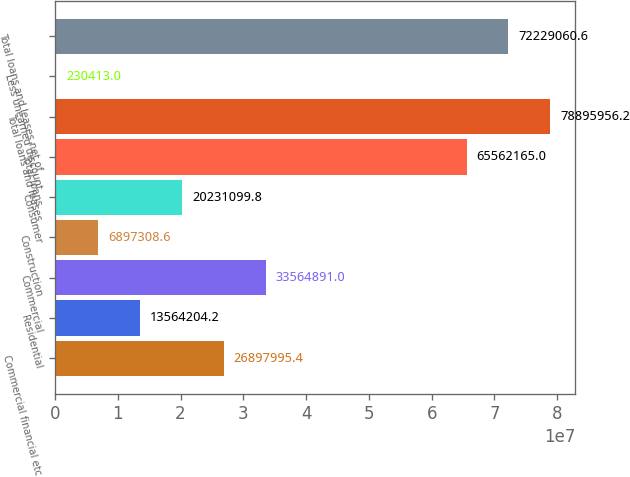Convert chart to OTSL. <chart><loc_0><loc_0><loc_500><loc_500><bar_chart><fcel>Commercial financial etc<fcel>Residential<fcel>Commercial<fcel>Construction<fcel>Consumer<fcel>Total loans<fcel>Total loans and leases<fcel>Less unearned discount<fcel>Total loans and leases net of<nl><fcel>2.6898e+07<fcel>1.35642e+07<fcel>3.35649e+07<fcel>6.89731e+06<fcel>2.02311e+07<fcel>6.55622e+07<fcel>7.8896e+07<fcel>230413<fcel>7.22291e+07<nl></chart> 